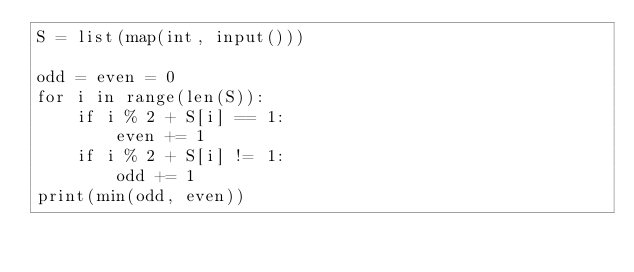<code> <loc_0><loc_0><loc_500><loc_500><_Python_>S = list(map(int, input()))

odd = even = 0
for i in range(len(S)):
    if i % 2 + S[i] == 1:
        even += 1
    if i % 2 + S[i] != 1:
        odd += 1
print(min(odd, even))</code> 